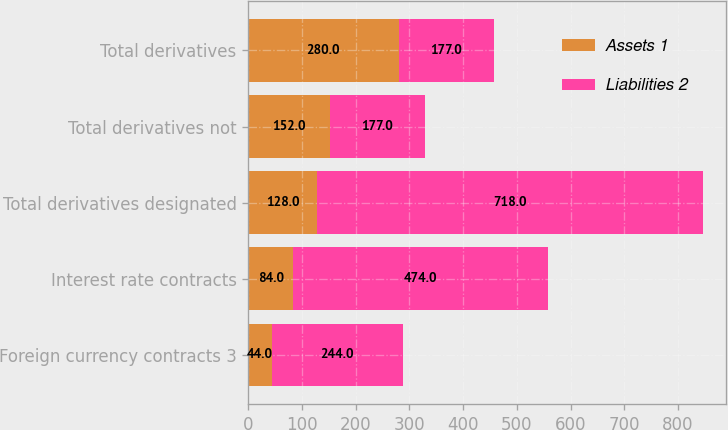Convert chart. <chart><loc_0><loc_0><loc_500><loc_500><stacked_bar_chart><ecel><fcel>Foreign currency contracts 3<fcel>Interest rate contracts<fcel>Total derivatives designated<fcel>Total derivatives not<fcel>Total derivatives<nl><fcel>Assets 1<fcel>44<fcel>84<fcel>128<fcel>152<fcel>280<nl><fcel>Liabilities 2<fcel>244<fcel>474<fcel>718<fcel>177<fcel>177<nl></chart> 